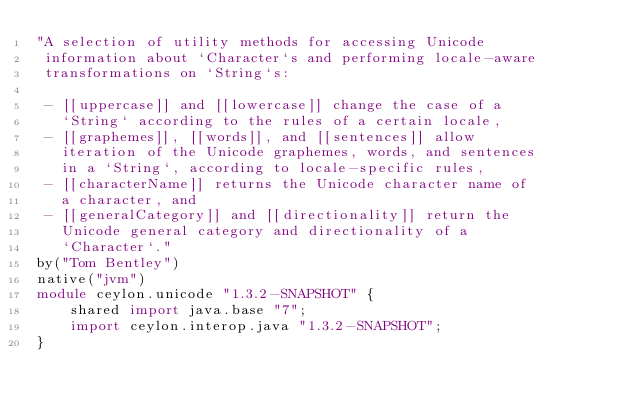<code> <loc_0><loc_0><loc_500><loc_500><_Ceylon_>"A selection of utility methods for accessing Unicode 
 information about `Character`s and performing locale-aware
 transformations on `String`s:
 
 - [[uppercase]] and [[lowercase]] change the case of a
   `String` according to the rules of a certain locale,
 - [[graphemes]], [[words]], and [[sentences]] allow 
   iteration of the Unicode graphemes, words, and sentences
   in a `String`, according to locale-specific rules,
 - [[characterName]] returns the Unicode character name of
   a character, and
 - [[generalCategory]] and [[directionality]] return the
   Unicode general category and directionality of a 
   `Character`."
by("Tom Bentley")
native("jvm")
module ceylon.unicode "1.3.2-SNAPSHOT" {
    shared import java.base "7";
    import ceylon.interop.java "1.3.2-SNAPSHOT";
}
</code> 